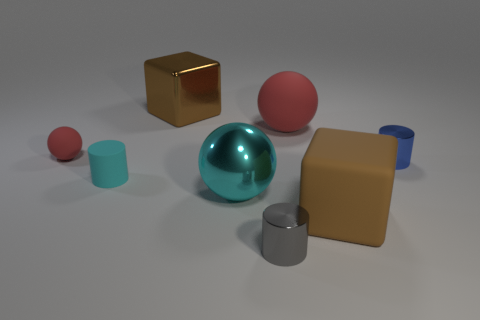Add 1 blue rubber blocks. How many objects exist? 9 Subtract all cubes. How many objects are left? 6 Subtract 1 cyan cylinders. How many objects are left? 7 Subtract all big rubber blocks. Subtract all small matte balls. How many objects are left? 6 Add 7 matte cylinders. How many matte cylinders are left? 8 Add 1 small purple matte cylinders. How many small purple matte cylinders exist? 1 